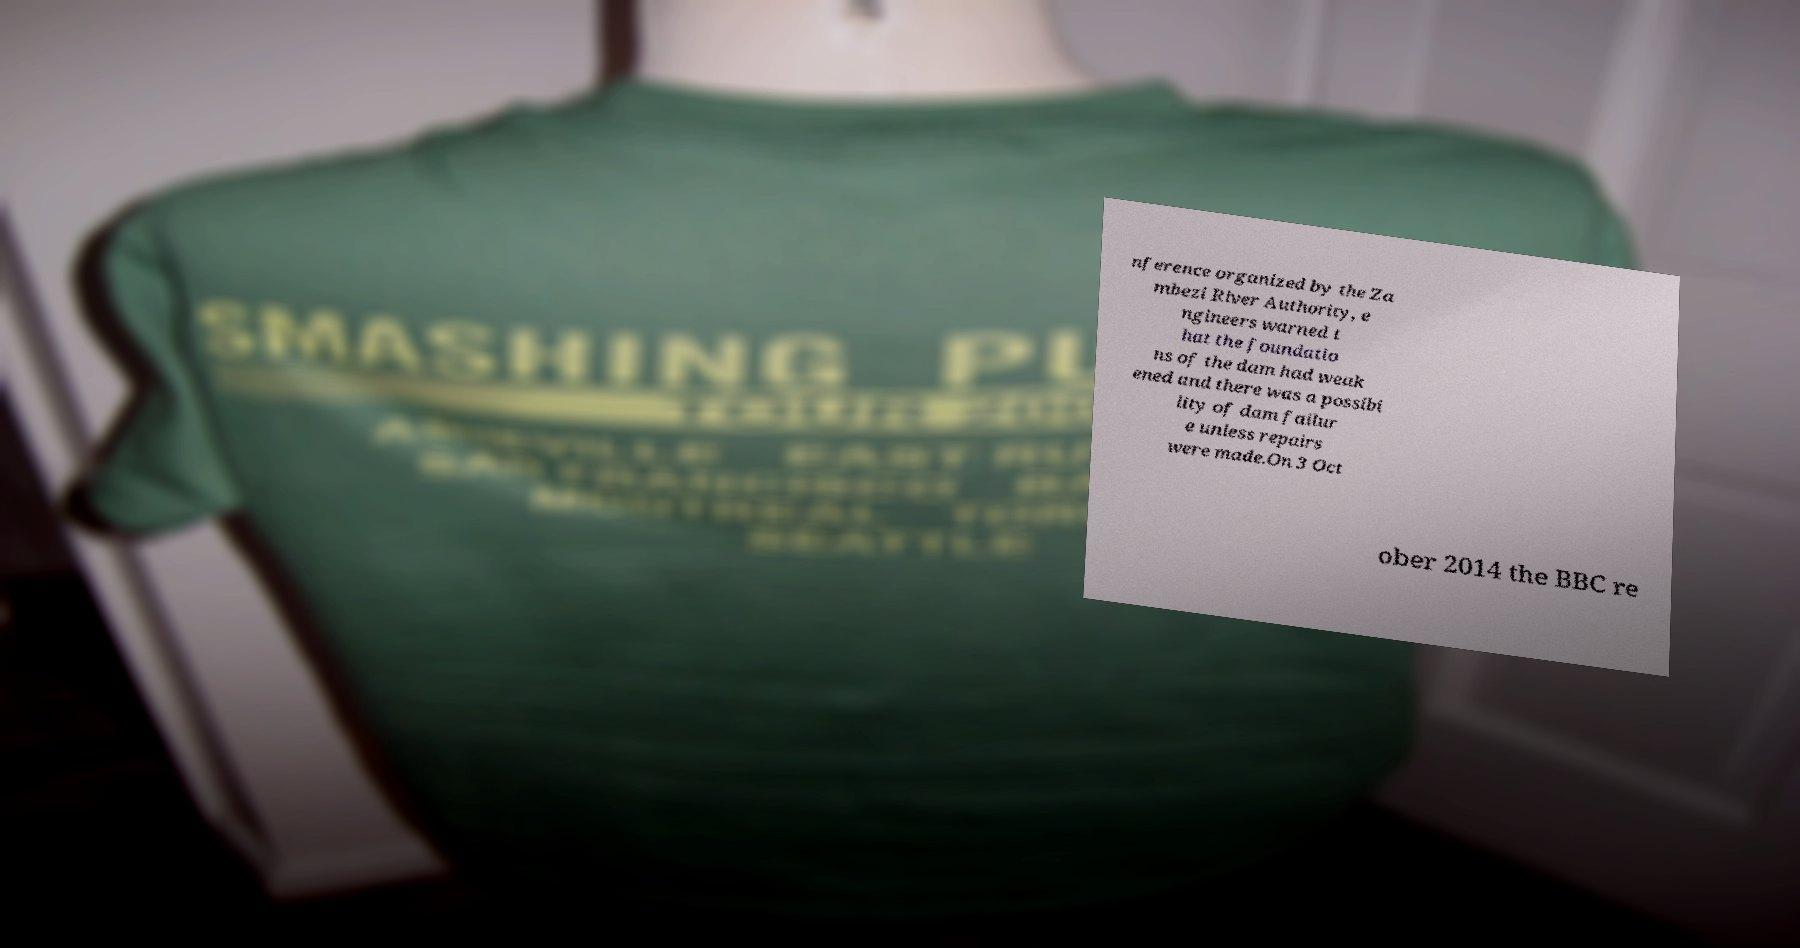Could you assist in decoding the text presented in this image and type it out clearly? nference organized by the Za mbezi River Authority, e ngineers warned t hat the foundatio ns of the dam had weak ened and there was a possibi lity of dam failur e unless repairs were made.On 3 Oct ober 2014 the BBC re 